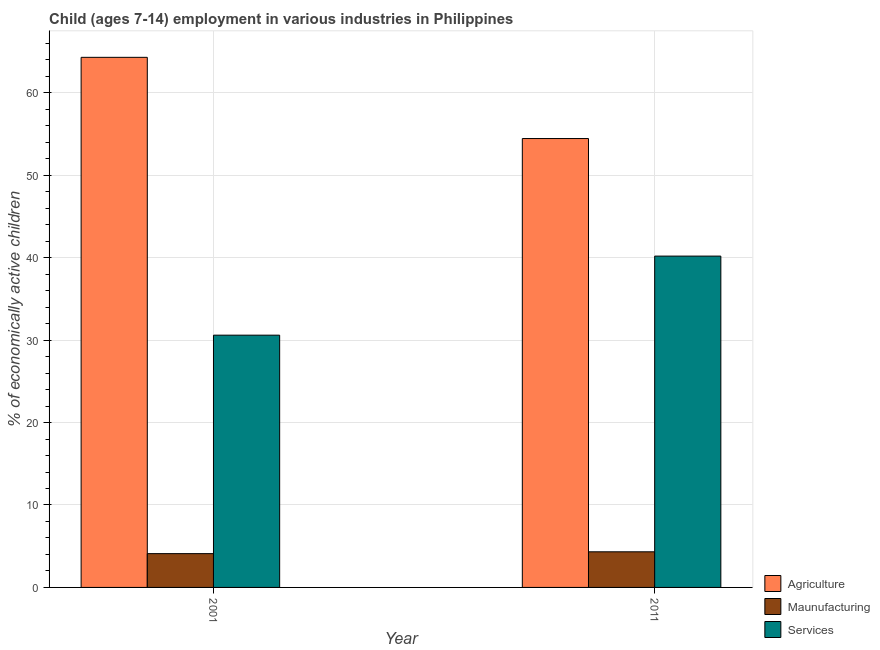How many different coloured bars are there?
Offer a terse response. 3. How many bars are there on the 1st tick from the right?
Your answer should be very brief. 3. What is the label of the 2nd group of bars from the left?
Ensure brevity in your answer.  2011. What is the percentage of economically active children in agriculture in 2001?
Make the answer very short. 64.3. Across all years, what is the maximum percentage of economically active children in services?
Offer a very short reply. 40.19. Across all years, what is the minimum percentage of economically active children in services?
Your response must be concise. 30.6. In which year was the percentage of economically active children in manufacturing minimum?
Give a very brief answer. 2001. What is the total percentage of economically active children in manufacturing in the graph?
Your response must be concise. 8.42. What is the difference between the percentage of economically active children in manufacturing in 2001 and that in 2011?
Ensure brevity in your answer.  -0.22. What is the difference between the percentage of economically active children in agriculture in 2011 and the percentage of economically active children in manufacturing in 2001?
Make the answer very short. -9.85. What is the average percentage of economically active children in agriculture per year?
Provide a succinct answer. 59.38. In the year 2011, what is the difference between the percentage of economically active children in agriculture and percentage of economically active children in manufacturing?
Provide a short and direct response. 0. In how many years, is the percentage of economically active children in services greater than 14 %?
Provide a short and direct response. 2. What is the ratio of the percentage of economically active children in services in 2001 to that in 2011?
Keep it short and to the point. 0.76. In how many years, is the percentage of economically active children in manufacturing greater than the average percentage of economically active children in manufacturing taken over all years?
Your answer should be very brief. 1. What does the 2nd bar from the left in 2001 represents?
Your response must be concise. Maunufacturing. What does the 1st bar from the right in 2011 represents?
Your response must be concise. Services. How many years are there in the graph?
Your answer should be very brief. 2. What is the difference between two consecutive major ticks on the Y-axis?
Offer a very short reply. 10. Are the values on the major ticks of Y-axis written in scientific E-notation?
Make the answer very short. No. How are the legend labels stacked?
Provide a succinct answer. Vertical. What is the title of the graph?
Provide a succinct answer. Child (ages 7-14) employment in various industries in Philippines. Does "Unemployment benefits" appear as one of the legend labels in the graph?
Offer a terse response. No. What is the label or title of the X-axis?
Provide a short and direct response. Year. What is the label or title of the Y-axis?
Your answer should be compact. % of economically active children. What is the % of economically active children of Agriculture in 2001?
Offer a terse response. 64.3. What is the % of economically active children in Maunufacturing in 2001?
Provide a succinct answer. 4.1. What is the % of economically active children of Services in 2001?
Ensure brevity in your answer.  30.6. What is the % of economically active children of Agriculture in 2011?
Make the answer very short. 54.45. What is the % of economically active children of Maunufacturing in 2011?
Your answer should be very brief. 4.32. What is the % of economically active children of Services in 2011?
Offer a terse response. 40.19. Across all years, what is the maximum % of economically active children in Agriculture?
Your answer should be compact. 64.3. Across all years, what is the maximum % of economically active children of Maunufacturing?
Offer a very short reply. 4.32. Across all years, what is the maximum % of economically active children in Services?
Your answer should be compact. 40.19. Across all years, what is the minimum % of economically active children in Agriculture?
Provide a succinct answer. 54.45. Across all years, what is the minimum % of economically active children of Services?
Your answer should be very brief. 30.6. What is the total % of economically active children of Agriculture in the graph?
Offer a very short reply. 118.75. What is the total % of economically active children of Maunufacturing in the graph?
Provide a short and direct response. 8.42. What is the total % of economically active children in Services in the graph?
Your response must be concise. 70.79. What is the difference between the % of economically active children of Agriculture in 2001 and that in 2011?
Make the answer very short. 9.85. What is the difference between the % of economically active children of Maunufacturing in 2001 and that in 2011?
Offer a terse response. -0.22. What is the difference between the % of economically active children in Services in 2001 and that in 2011?
Ensure brevity in your answer.  -9.59. What is the difference between the % of economically active children in Agriculture in 2001 and the % of economically active children in Maunufacturing in 2011?
Provide a succinct answer. 59.98. What is the difference between the % of economically active children in Agriculture in 2001 and the % of economically active children in Services in 2011?
Your response must be concise. 24.11. What is the difference between the % of economically active children in Maunufacturing in 2001 and the % of economically active children in Services in 2011?
Make the answer very short. -36.09. What is the average % of economically active children in Agriculture per year?
Your answer should be very brief. 59.38. What is the average % of economically active children of Maunufacturing per year?
Provide a short and direct response. 4.21. What is the average % of economically active children of Services per year?
Provide a short and direct response. 35.4. In the year 2001, what is the difference between the % of economically active children in Agriculture and % of economically active children in Maunufacturing?
Your answer should be compact. 60.2. In the year 2001, what is the difference between the % of economically active children in Agriculture and % of economically active children in Services?
Offer a terse response. 33.7. In the year 2001, what is the difference between the % of economically active children of Maunufacturing and % of economically active children of Services?
Your response must be concise. -26.5. In the year 2011, what is the difference between the % of economically active children in Agriculture and % of economically active children in Maunufacturing?
Offer a terse response. 50.13. In the year 2011, what is the difference between the % of economically active children of Agriculture and % of economically active children of Services?
Give a very brief answer. 14.26. In the year 2011, what is the difference between the % of economically active children of Maunufacturing and % of economically active children of Services?
Your answer should be compact. -35.87. What is the ratio of the % of economically active children in Agriculture in 2001 to that in 2011?
Ensure brevity in your answer.  1.18. What is the ratio of the % of economically active children in Maunufacturing in 2001 to that in 2011?
Keep it short and to the point. 0.95. What is the ratio of the % of economically active children of Services in 2001 to that in 2011?
Your answer should be compact. 0.76. What is the difference between the highest and the second highest % of economically active children of Agriculture?
Offer a very short reply. 9.85. What is the difference between the highest and the second highest % of economically active children in Maunufacturing?
Provide a short and direct response. 0.22. What is the difference between the highest and the second highest % of economically active children in Services?
Make the answer very short. 9.59. What is the difference between the highest and the lowest % of economically active children in Agriculture?
Your answer should be compact. 9.85. What is the difference between the highest and the lowest % of economically active children in Maunufacturing?
Your answer should be very brief. 0.22. What is the difference between the highest and the lowest % of economically active children of Services?
Your answer should be very brief. 9.59. 